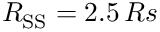<formula> <loc_0><loc_0><loc_500><loc_500>R _ { S S } = 2 . 5 \, R s</formula> 